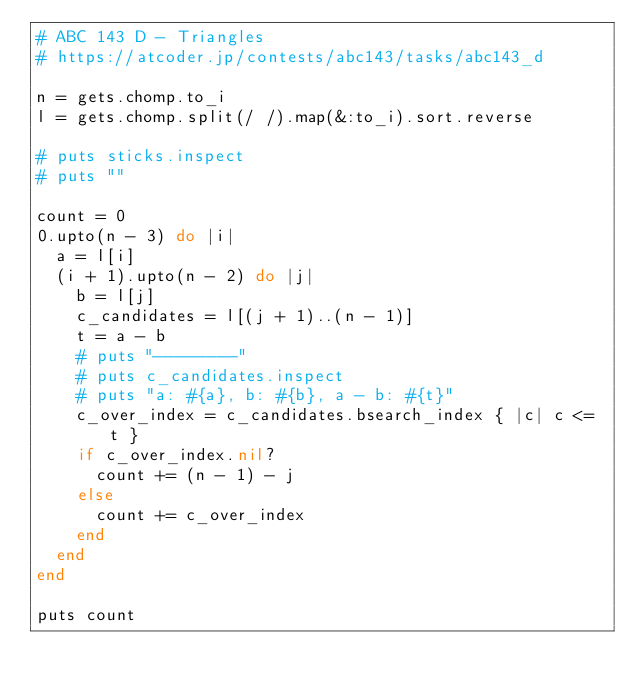Convert code to text. <code><loc_0><loc_0><loc_500><loc_500><_Ruby_># ABC 143 D - Triangles
# https://atcoder.jp/contests/abc143/tasks/abc143_d

n = gets.chomp.to_i
l = gets.chomp.split(/ /).map(&:to_i).sort.reverse

# puts sticks.inspect
# puts ""

count = 0
0.upto(n - 3) do |i|
  a = l[i]
  (i + 1).upto(n - 2) do |j|
    b = l[j]
    c_candidates = l[(j + 1)..(n - 1)]
    t = a - b
    # puts "--------"
    # puts c_candidates.inspect
    # puts "a: #{a}, b: #{b}, a - b: #{t}"
    c_over_index = c_candidates.bsearch_index { |c| c <= t }
    if c_over_index.nil?
      count += (n - 1) - j
    else
      count += c_over_index
    end
  end
end

puts count
</code> 